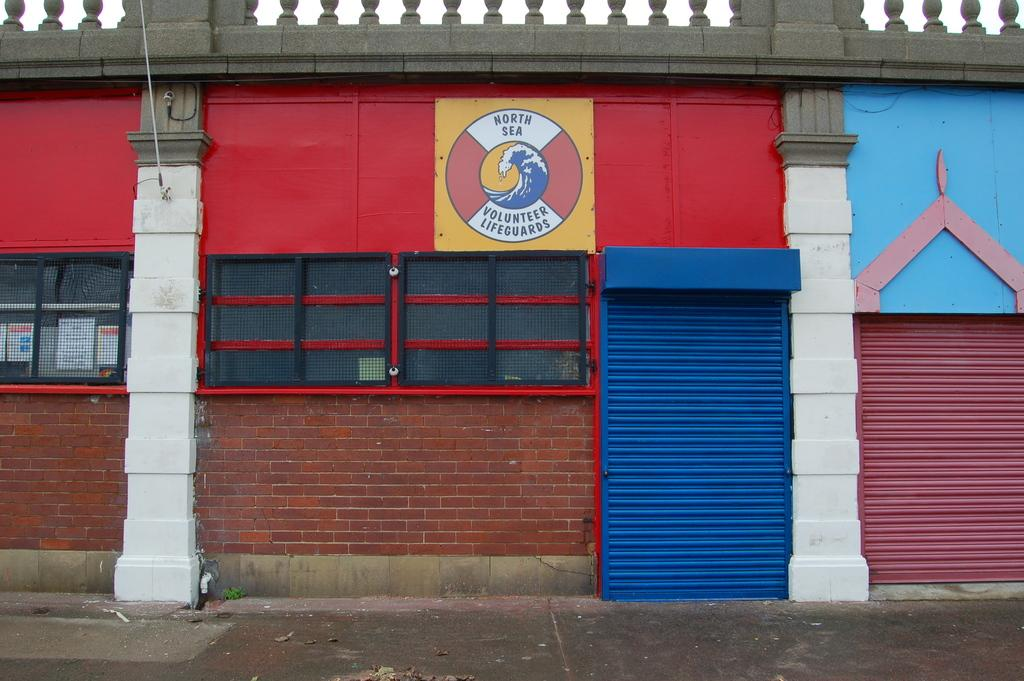What type of shutters are visible in the image? There are rolling shutters in the image. What structure is present in the image? There is a building in the image. Where are the papers located in the image? The papers are on the left side of the image. How many people are in the crowd on the right side of the image? There is no crowd present in the image; it only features rolling shutters, a building, and papers. What type of book is visible on the left side of the image? There is no book present in the image; it only features papers on the left side. 